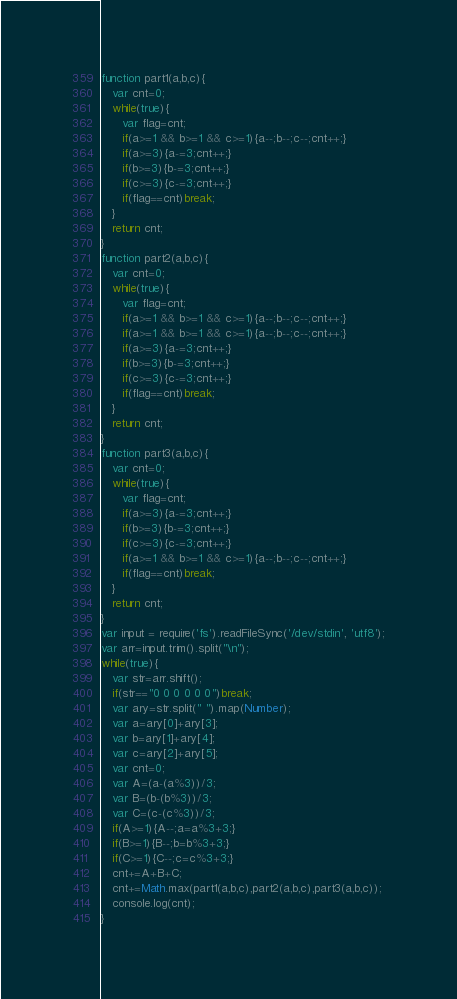Convert code to text. <code><loc_0><loc_0><loc_500><loc_500><_JavaScript_>function part1(a,b,c){
   var cnt=0;
   while(true){
      var flag=cnt;
      if(a>=1 && b>=1 && c>=1){a--;b--;c--;cnt++;}
      if(a>=3){a-=3;cnt++;}
      if(b>=3){b-=3;cnt++;}
      if(c>=3){c-=3;cnt++;}
      if(flag==cnt)break;
   }
   return cnt;
}
function part2(a,b,c){
   var cnt=0;
   while(true){
      var flag=cnt;
      if(a>=1 && b>=1 && c>=1){a--;b--;c--;cnt++;}
      if(a>=1 && b>=1 && c>=1){a--;b--;c--;cnt++;}
      if(a>=3){a-=3;cnt++;}
      if(b>=3){b-=3;cnt++;}
      if(c>=3){c-=3;cnt++;}
      if(flag==cnt)break;
   }
   return cnt;
}
function part3(a,b,c){
   var cnt=0;
   while(true){
      var flag=cnt;
      if(a>=3){a-=3;cnt++;}
      if(b>=3){b-=3;cnt++;}
      if(c>=3){c-=3;cnt++;}
      if(a>=1 && b>=1 && c>=1){a--;b--;c--;cnt++;}
      if(flag==cnt)break;
   }
   return cnt;
}
var input = require('fs').readFileSync('/dev/stdin', 'utf8');
var arr=input.trim().split("\n");
while(true){
   var str=arr.shift();
   if(str=="0 0 0 0 0 0")break;
   var ary=str.split(" ").map(Number);
   var a=ary[0]+ary[3];
   var b=ary[1]+ary[4];
   var c=ary[2]+ary[5];
   var cnt=0;
   var A=(a-(a%3))/3;
   var B=(b-(b%3))/3;
   var C=(c-(c%3))/3;
   if(A>=1){A--;a=a%3+3;}
   if(B>=1){B--;b=b%3+3;}
   if(C>=1){C--;c=c%3+3;}
   cnt+=A+B+C;
   cnt+=Math.max(part1(a,b,c),part2(a,b,c),part3(a,b,c));
   console.log(cnt);
}</code> 